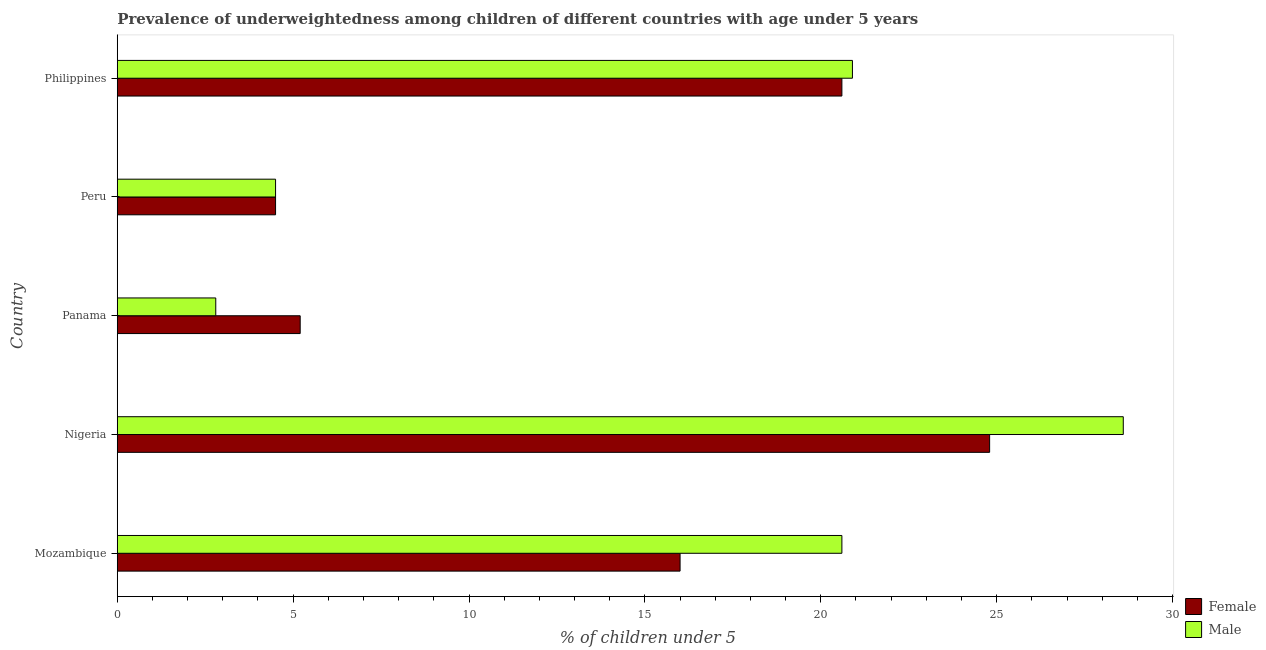How many groups of bars are there?
Make the answer very short. 5. Are the number of bars per tick equal to the number of legend labels?
Give a very brief answer. Yes. What is the label of the 4th group of bars from the top?
Your response must be concise. Nigeria. In how many cases, is the number of bars for a given country not equal to the number of legend labels?
Offer a terse response. 0. What is the percentage of underweighted female children in Philippines?
Provide a succinct answer. 20.6. Across all countries, what is the maximum percentage of underweighted male children?
Offer a terse response. 28.6. Across all countries, what is the minimum percentage of underweighted female children?
Make the answer very short. 4.5. In which country was the percentage of underweighted female children maximum?
Provide a succinct answer. Nigeria. What is the total percentage of underweighted female children in the graph?
Offer a terse response. 71.1. What is the difference between the percentage of underweighted male children in Mozambique and that in Nigeria?
Give a very brief answer. -8. What is the average percentage of underweighted male children per country?
Offer a terse response. 15.48. What is the difference between the percentage of underweighted female children and percentage of underweighted male children in Peru?
Make the answer very short. 0. In how many countries, is the percentage of underweighted female children greater than 21 %?
Give a very brief answer. 1. What is the ratio of the percentage of underweighted female children in Peru to that in Philippines?
Your response must be concise. 0.22. Is the percentage of underweighted male children in Mozambique less than that in Nigeria?
Ensure brevity in your answer.  Yes. Is the difference between the percentage of underweighted female children in Mozambique and Panama greater than the difference between the percentage of underweighted male children in Mozambique and Panama?
Offer a terse response. No. What is the difference between the highest and the second highest percentage of underweighted female children?
Make the answer very short. 4.2. What is the difference between the highest and the lowest percentage of underweighted male children?
Your answer should be compact. 25.8. In how many countries, is the percentage of underweighted male children greater than the average percentage of underweighted male children taken over all countries?
Keep it short and to the point. 3. Is the sum of the percentage of underweighted male children in Mozambique and Peru greater than the maximum percentage of underweighted female children across all countries?
Offer a terse response. Yes. What does the 2nd bar from the top in Mozambique represents?
Your response must be concise. Female. Does the graph contain grids?
Your response must be concise. No. Where does the legend appear in the graph?
Your answer should be compact. Bottom right. What is the title of the graph?
Make the answer very short. Prevalence of underweightedness among children of different countries with age under 5 years. What is the label or title of the X-axis?
Offer a terse response.  % of children under 5. What is the  % of children under 5 in Female in Mozambique?
Keep it short and to the point. 16. What is the  % of children under 5 of Male in Mozambique?
Your answer should be very brief. 20.6. What is the  % of children under 5 in Female in Nigeria?
Your answer should be compact. 24.8. What is the  % of children under 5 of Male in Nigeria?
Keep it short and to the point. 28.6. What is the  % of children under 5 in Female in Panama?
Your answer should be very brief. 5.2. What is the  % of children under 5 in Male in Panama?
Provide a succinct answer. 2.8. What is the  % of children under 5 in Male in Peru?
Provide a succinct answer. 4.5. What is the  % of children under 5 in Female in Philippines?
Give a very brief answer. 20.6. What is the  % of children under 5 of Male in Philippines?
Your answer should be compact. 20.9. Across all countries, what is the maximum  % of children under 5 of Female?
Keep it short and to the point. 24.8. Across all countries, what is the maximum  % of children under 5 of Male?
Keep it short and to the point. 28.6. Across all countries, what is the minimum  % of children under 5 of Male?
Keep it short and to the point. 2.8. What is the total  % of children under 5 of Female in the graph?
Your answer should be very brief. 71.1. What is the total  % of children under 5 of Male in the graph?
Provide a succinct answer. 77.4. What is the difference between the  % of children under 5 in Female in Mozambique and that in Nigeria?
Your answer should be very brief. -8.8. What is the difference between the  % of children under 5 in Male in Mozambique and that in Nigeria?
Your response must be concise. -8. What is the difference between the  % of children under 5 in Male in Mozambique and that in Panama?
Ensure brevity in your answer.  17.8. What is the difference between the  % of children under 5 in Female in Mozambique and that in Philippines?
Make the answer very short. -4.6. What is the difference between the  % of children under 5 in Male in Mozambique and that in Philippines?
Your answer should be compact. -0.3. What is the difference between the  % of children under 5 in Female in Nigeria and that in Panama?
Make the answer very short. 19.6. What is the difference between the  % of children under 5 of Male in Nigeria and that in Panama?
Your answer should be compact. 25.8. What is the difference between the  % of children under 5 in Female in Nigeria and that in Peru?
Your answer should be compact. 20.3. What is the difference between the  % of children under 5 in Male in Nigeria and that in Peru?
Provide a succinct answer. 24.1. What is the difference between the  % of children under 5 of Female in Panama and that in Peru?
Provide a succinct answer. 0.7. What is the difference between the  % of children under 5 of Female in Panama and that in Philippines?
Offer a terse response. -15.4. What is the difference between the  % of children under 5 of Male in Panama and that in Philippines?
Give a very brief answer. -18.1. What is the difference between the  % of children under 5 of Female in Peru and that in Philippines?
Give a very brief answer. -16.1. What is the difference between the  % of children under 5 of Male in Peru and that in Philippines?
Your answer should be very brief. -16.4. What is the difference between the  % of children under 5 of Female in Mozambique and the  % of children under 5 of Male in Nigeria?
Make the answer very short. -12.6. What is the difference between the  % of children under 5 in Female in Mozambique and the  % of children under 5 in Male in Panama?
Offer a very short reply. 13.2. What is the difference between the  % of children under 5 of Female in Nigeria and the  % of children under 5 of Male in Peru?
Your response must be concise. 20.3. What is the difference between the  % of children under 5 of Female in Nigeria and the  % of children under 5 of Male in Philippines?
Make the answer very short. 3.9. What is the difference between the  % of children under 5 of Female in Panama and the  % of children under 5 of Male in Philippines?
Provide a succinct answer. -15.7. What is the difference between the  % of children under 5 of Female in Peru and the  % of children under 5 of Male in Philippines?
Your answer should be very brief. -16.4. What is the average  % of children under 5 in Female per country?
Offer a terse response. 14.22. What is the average  % of children under 5 in Male per country?
Give a very brief answer. 15.48. What is the difference between the  % of children under 5 of Female and  % of children under 5 of Male in Mozambique?
Make the answer very short. -4.6. What is the difference between the  % of children under 5 of Female and  % of children under 5 of Male in Nigeria?
Your answer should be compact. -3.8. What is the difference between the  % of children under 5 in Female and  % of children under 5 in Male in Philippines?
Make the answer very short. -0.3. What is the ratio of the  % of children under 5 of Female in Mozambique to that in Nigeria?
Your answer should be very brief. 0.65. What is the ratio of the  % of children under 5 of Male in Mozambique to that in Nigeria?
Keep it short and to the point. 0.72. What is the ratio of the  % of children under 5 in Female in Mozambique to that in Panama?
Provide a succinct answer. 3.08. What is the ratio of the  % of children under 5 of Male in Mozambique to that in Panama?
Offer a very short reply. 7.36. What is the ratio of the  % of children under 5 of Female in Mozambique to that in Peru?
Provide a succinct answer. 3.56. What is the ratio of the  % of children under 5 in Male in Mozambique to that in Peru?
Your response must be concise. 4.58. What is the ratio of the  % of children under 5 of Female in Mozambique to that in Philippines?
Your response must be concise. 0.78. What is the ratio of the  % of children under 5 in Male in Mozambique to that in Philippines?
Your answer should be compact. 0.99. What is the ratio of the  % of children under 5 of Female in Nigeria to that in Panama?
Provide a succinct answer. 4.77. What is the ratio of the  % of children under 5 of Male in Nigeria to that in Panama?
Keep it short and to the point. 10.21. What is the ratio of the  % of children under 5 in Female in Nigeria to that in Peru?
Ensure brevity in your answer.  5.51. What is the ratio of the  % of children under 5 in Male in Nigeria to that in Peru?
Ensure brevity in your answer.  6.36. What is the ratio of the  % of children under 5 of Female in Nigeria to that in Philippines?
Give a very brief answer. 1.2. What is the ratio of the  % of children under 5 of Male in Nigeria to that in Philippines?
Keep it short and to the point. 1.37. What is the ratio of the  % of children under 5 in Female in Panama to that in Peru?
Your response must be concise. 1.16. What is the ratio of the  % of children under 5 in Male in Panama to that in Peru?
Your answer should be very brief. 0.62. What is the ratio of the  % of children under 5 of Female in Panama to that in Philippines?
Your answer should be very brief. 0.25. What is the ratio of the  % of children under 5 of Male in Panama to that in Philippines?
Offer a terse response. 0.13. What is the ratio of the  % of children under 5 of Female in Peru to that in Philippines?
Your answer should be very brief. 0.22. What is the ratio of the  % of children under 5 in Male in Peru to that in Philippines?
Your answer should be compact. 0.22. What is the difference between the highest and the lowest  % of children under 5 in Female?
Your answer should be very brief. 20.3. What is the difference between the highest and the lowest  % of children under 5 of Male?
Your answer should be compact. 25.8. 